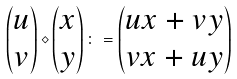Convert formula to latex. <formula><loc_0><loc_0><loc_500><loc_500>\begin{pmatrix} u \\ v \end{pmatrix} \diamond \begin{pmatrix} x \\ y \end{pmatrix} \colon = \begin{pmatrix} u x + v y \\ v x + u y \end{pmatrix}</formula> 